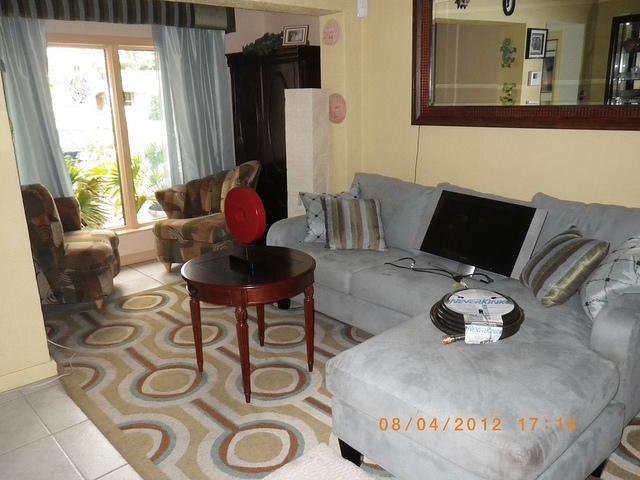What is on the couch?
Answer the question by selecting the correct answer among the 4 following choices and explain your choice with a short sentence. The answer should be formatted with the following format: `Answer: choice
Rationale: rationale.`
Options: Apple, egg carton, hose, cat. Answer: hose.
Rationale: There is a brand new black water hose on the couch still in the packaging. 